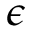Convert formula to latex. <formula><loc_0><loc_0><loc_500><loc_500>\epsilon</formula> 